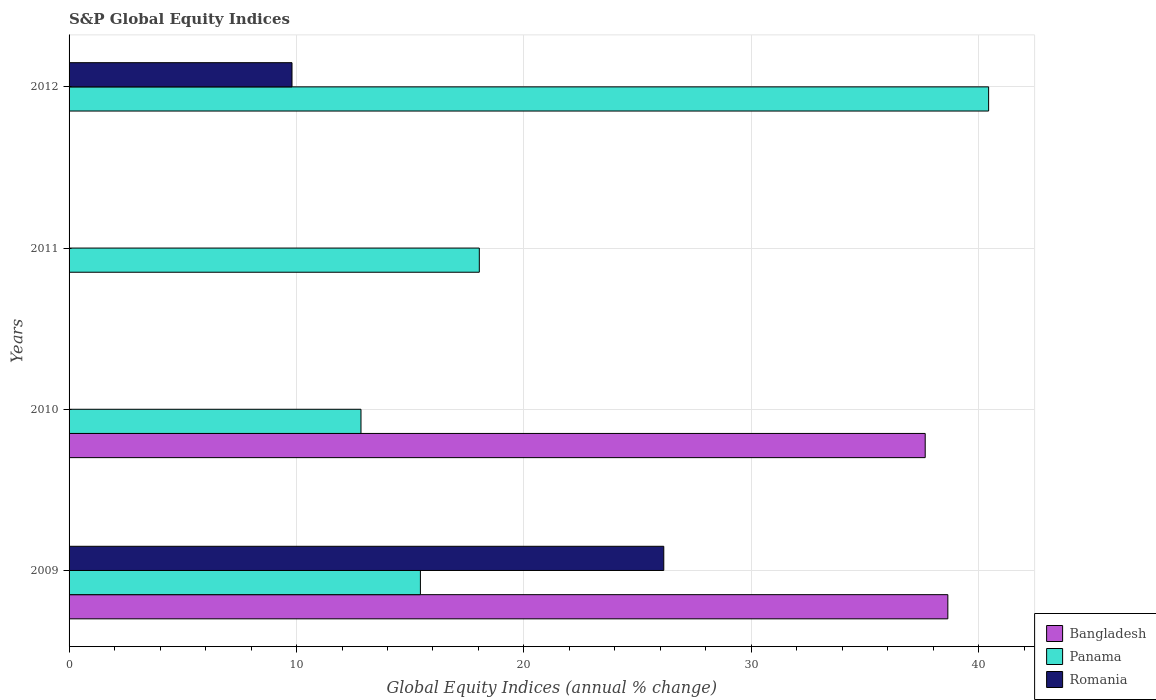How many bars are there on the 1st tick from the bottom?
Your answer should be very brief. 3. What is the label of the 1st group of bars from the top?
Your response must be concise. 2012. What is the global equity indices in Panama in 2010?
Your response must be concise. 12.83. Across all years, what is the maximum global equity indices in Bangladesh?
Your answer should be very brief. 38.64. What is the total global equity indices in Bangladesh in the graph?
Offer a very short reply. 76.28. What is the difference between the global equity indices in Panama in 2011 and that in 2012?
Your answer should be compact. -22.39. What is the difference between the global equity indices in Bangladesh in 2009 and the global equity indices in Panama in 2012?
Offer a very short reply. -1.79. What is the average global equity indices in Panama per year?
Your response must be concise. 21.69. In the year 2012, what is the difference between the global equity indices in Panama and global equity indices in Romania?
Your answer should be compact. 30.63. In how many years, is the global equity indices in Romania greater than 24 %?
Your answer should be compact. 1. What is the ratio of the global equity indices in Romania in 2009 to that in 2012?
Make the answer very short. 2.67. What is the difference between the highest and the second highest global equity indices in Panama?
Ensure brevity in your answer.  22.39. What is the difference between the highest and the lowest global equity indices in Panama?
Ensure brevity in your answer.  27.59. Is the sum of the global equity indices in Panama in 2010 and 2011 greater than the maximum global equity indices in Romania across all years?
Provide a succinct answer. Yes. Is it the case that in every year, the sum of the global equity indices in Romania and global equity indices in Panama is greater than the global equity indices in Bangladesh?
Your answer should be compact. No. How many bars are there?
Ensure brevity in your answer.  8. Are all the bars in the graph horizontal?
Your answer should be very brief. Yes. Are the values on the major ticks of X-axis written in scientific E-notation?
Your answer should be very brief. No. What is the title of the graph?
Ensure brevity in your answer.  S&P Global Equity Indices. Does "France" appear as one of the legend labels in the graph?
Your response must be concise. No. What is the label or title of the X-axis?
Provide a short and direct response. Global Equity Indices (annual % change). What is the label or title of the Y-axis?
Your answer should be very brief. Years. What is the Global Equity Indices (annual % change) of Bangladesh in 2009?
Offer a very short reply. 38.64. What is the Global Equity Indices (annual % change) in Panama in 2009?
Offer a very short reply. 15.45. What is the Global Equity Indices (annual % change) in Romania in 2009?
Offer a very short reply. 26.15. What is the Global Equity Indices (annual % change) in Bangladesh in 2010?
Provide a succinct answer. 37.64. What is the Global Equity Indices (annual % change) in Panama in 2010?
Provide a short and direct response. 12.83. What is the Global Equity Indices (annual % change) in Romania in 2010?
Ensure brevity in your answer.  0. What is the Global Equity Indices (annual % change) of Bangladesh in 2011?
Provide a succinct answer. 0. What is the Global Equity Indices (annual % change) in Panama in 2011?
Provide a short and direct response. 18.04. What is the Global Equity Indices (annual % change) in Romania in 2011?
Your answer should be very brief. 0. What is the Global Equity Indices (annual % change) in Panama in 2012?
Your answer should be compact. 40.43. What is the Global Equity Indices (annual % change) in Romania in 2012?
Ensure brevity in your answer.  9.8. Across all years, what is the maximum Global Equity Indices (annual % change) in Bangladesh?
Offer a very short reply. 38.64. Across all years, what is the maximum Global Equity Indices (annual % change) of Panama?
Your answer should be compact. 40.43. Across all years, what is the maximum Global Equity Indices (annual % change) in Romania?
Provide a succinct answer. 26.15. Across all years, what is the minimum Global Equity Indices (annual % change) of Panama?
Your response must be concise. 12.83. What is the total Global Equity Indices (annual % change) in Bangladesh in the graph?
Offer a very short reply. 76.28. What is the total Global Equity Indices (annual % change) of Panama in the graph?
Ensure brevity in your answer.  86.75. What is the total Global Equity Indices (annual % change) of Romania in the graph?
Offer a very short reply. 35.95. What is the difference between the Global Equity Indices (annual % change) of Bangladesh in 2009 and that in 2010?
Your answer should be very brief. 1. What is the difference between the Global Equity Indices (annual % change) of Panama in 2009 and that in 2010?
Provide a succinct answer. 2.61. What is the difference between the Global Equity Indices (annual % change) of Panama in 2009 and that in 2011?
Keep it short and to the point. -2.59. What is the difference between the Global Equity Indices (annual % change) of Panama in 2009 and that in 2012?
Your answer should be compact. -24.98. What is the difference between the Global Equity Indices (annual % change) of Romania in 2009 and that in 2012?
Provide a short and direct response. 16.35. What is the difference between the Global Equity Indices (annual % change) in Panama in 2010 and that in 2011?
Your response must be concise. -5.2. What is the difference between the Global Equity Indices (annual % change) of Panama in 2010 and that in 2012?
Your response must be concise. -27.59. What is the difference between the Global Equity Indices (annual % change) of Panama in 2011 and that in 2012?
Offer a terse response. -22.39. What is the difference between the Global Equity Indices (annual % change) in Bangladesh in 2009 and the Global Equity Indices (annual % change) in Panama in 2010?
Your answer should be very brief. 25.8. What is the difference between the Global Equity Indices (annual % change) of Bangladesh in 2009 and the Global Equity Indices (annual % change) of Panama in 2011?
Your answer should be very brief. 20.6. What is the difference between the Global Equity Indices (annual % change) of Bangladesh in 2009 and the Global Equity Indices (annual % change) of Panama in 2012?
Make the answer very short. -1.79. What is the difference between the Global Equity Indices (annual % change) of Bangladesh in 2009 and the Global Equity Indices (annual % change) of Romania in 2012?
Your answer should be very brief. 28.84. What is the difference between the Global Equity Indices (annual % change) of Panama in 2009 and the Global Equity Indices (annual % change) of Romania in 2012?
Provide a succinct answer. 5.65. What is the difference between the Global Equity Indices (annual % change) of Bangladesh in 2010 and the Global Equity Indices (annual % change) of Panama in 2011?
Give a very brief answer. 19.6. What is the difference between the Global Equity Indices (annual % change) in Bangladesh in 2010 and the Global Equity Indices (annual % change) in Panama in 2012?
Keep it short and to the point. -2.79. What is the difference between the Global Equity Indices (annual % change) in Bangladesh in 2010 and the Global Equity Indices (annual % change) in Romania in 2012?
Your answer should be compact. 27.84. What is the difference between the Global Equity Indices (annual % change) of Panama in 2010 and the Global Equity Indices (annual % change) of Romania in 2012?
Keep it short and to the point. 3.03. What is the difference between the Global Equity Indices (annual % change) in Panama in 2011 and the Global Equity Indices (annual % change) in Romania in 2012?
Your answer should be very brief. 8.24. What is the average Global Equity Indices (annual % change) of Bangladesh per year?
Ensure brevity in your answer.  19.07. What is the average Global Equity Indices (annual % change) of Panama per year?
Offer a very short reply. 21.69. What is the average Global Equity Indices (annual % change) of Romania per year?
Your answer should be compact. 8.99. In the year 2009, what is the difference between the Global Equity Indices (annual % change) of Bangladesh and Global Equity Indices (annual % change) of Panama?
Your response must be concise. 23.19. In the year 2009, what is the difference between the Global Equity Indices (annual % change) of Bangladesh and Global Equity Indices (annual % change) of Romania?
Your response must be concise. 12.49. In the year 2009, what is the difference between the Global Equity Indices (annual % change) in Panama and Global Equity Indices (annual % change) in Romania?
Your answer should be compact. -10.7. In the year 2010, what is the difference between the Global Equity Indices (annual % change) in Bangladesh and Global Equity Indices (annual % change) in Panama?
Offer a terse response. 24.81. In the year 2012, what is the difference between the Global Equity Indices (annual % change) in Panama and Global Equity Indices (annual % change) in Romania?
Your answer should be very brief. 30.63. What is the ratio of the Global Equity Indices (annual % change) of Bangladesh in 2009 to that in 2010?
Offer a very short reply. 1.03. What is the ratio of the Global Equity Indices (annual % change) in Panama in 2009 to that in 2010?
Keep it short and to the point. 1.2. What is the ratio of the Global Equity Indices (annual % change) in Panama in 2009 to that in 2011?
Offer a terse response. 0.86. What is the ratio of the Global Equity Indices (annual % change) in Panama in 2009 to that in 2012?
Your answer should be very brief. 0.38. What is the ratio of the Global Equity Indices (annual % change) of Romania in 2009 to that in 2012?
Offer a very short reply. 2.67. What is the ratio of the Global Equity Indices (annual % change) of Panama in 2010 to that in 2011?
Your response must be concise. 0.71. What is the ratio of the Global Equity Indices (annual % change) in Panama in 2010 to that in 2012?
Give a very brief answer. 0.32. What is the ratio of the Global Equity Indices (annual % change) of Panama in 2011 to that in 2012?
Ensure brevity in your answer.  0.45. What is the difference between the highest and the second highest Global Equity Indices (annual % change) in Panama?
Your response must be concise. 22.39. What is the difference between the highest and the lowest Global Equity Indices (annual % change) of Bangladesh?
Give a very brief answer. 38.64. What is the difference between the highest and the lowest Global Equity Indices (annual % change) in Panama?
Make the answer very short. 27.59. What is the difference between the highest and the lowest Global Equity Indices (annual % change) of Romania?
Give a very brief answer. 26.15. 